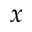<formula> <loc_0><loc_0><loc_500><loc_500>x</formula> 